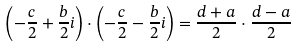Convert formula to latex. <formula><loc_0><loc_0><loc_500><loc_500>\left ( - \frac { c } { 2 } + \frac { b } { 2 } i \right ) \cdot \left ( - \frac { c } { 2 } - \frac { b } { 2 } i \right ) = \frac { d + a } { 2 } \cdot \frac { d - a } { 2 }</formula> 